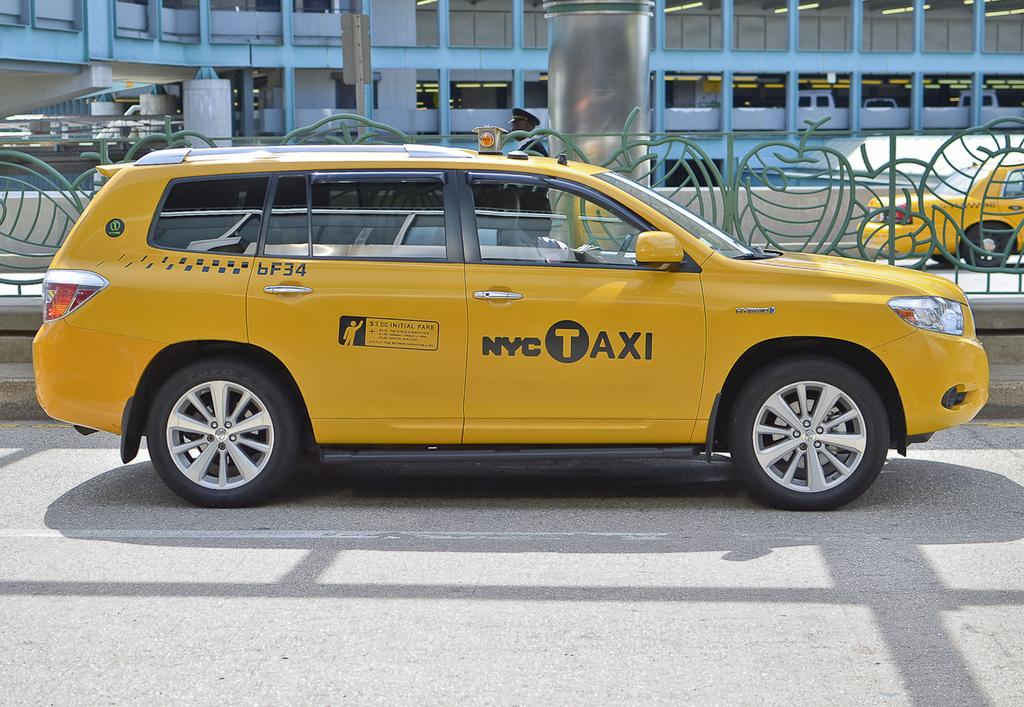Provide a one-sentence caption for the provided image. Initial fare is $3 on this NYC Taxi. 